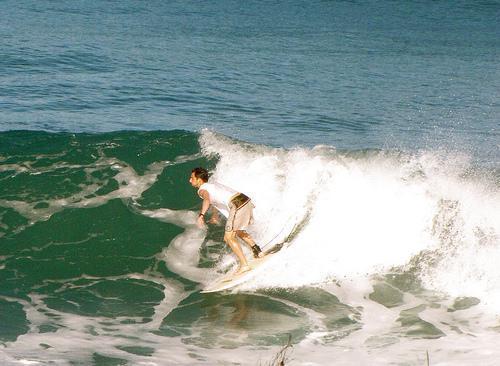How many people are there?
Give a very brief answer. 1. 